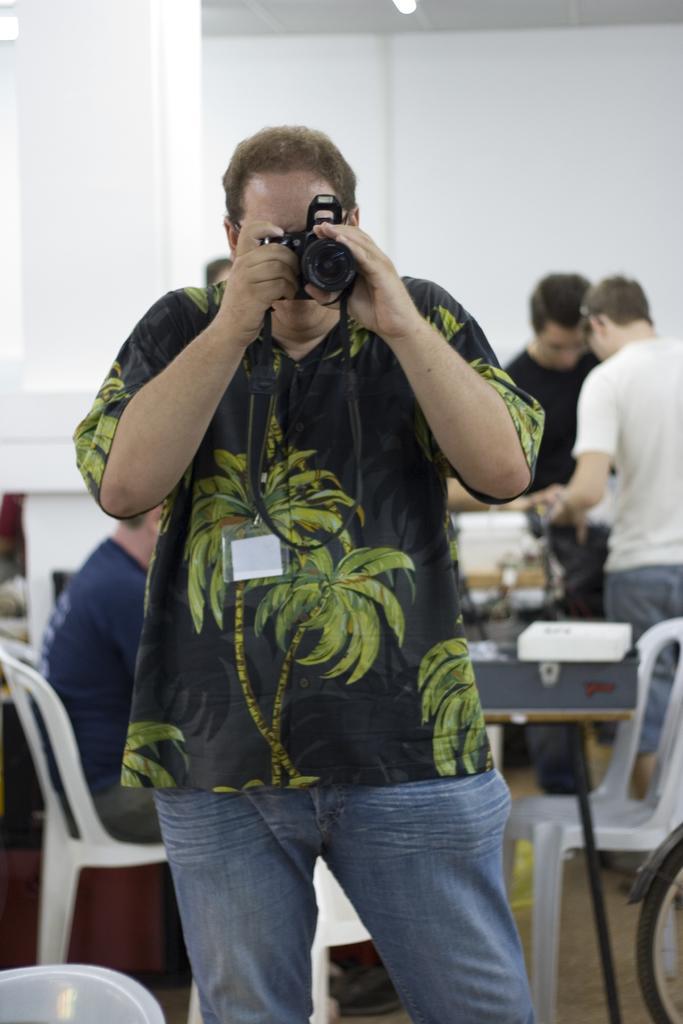Could you give a brief overview of what you see in this image? He is standing and his holding a camera. We can see the background there is a table and persons. 